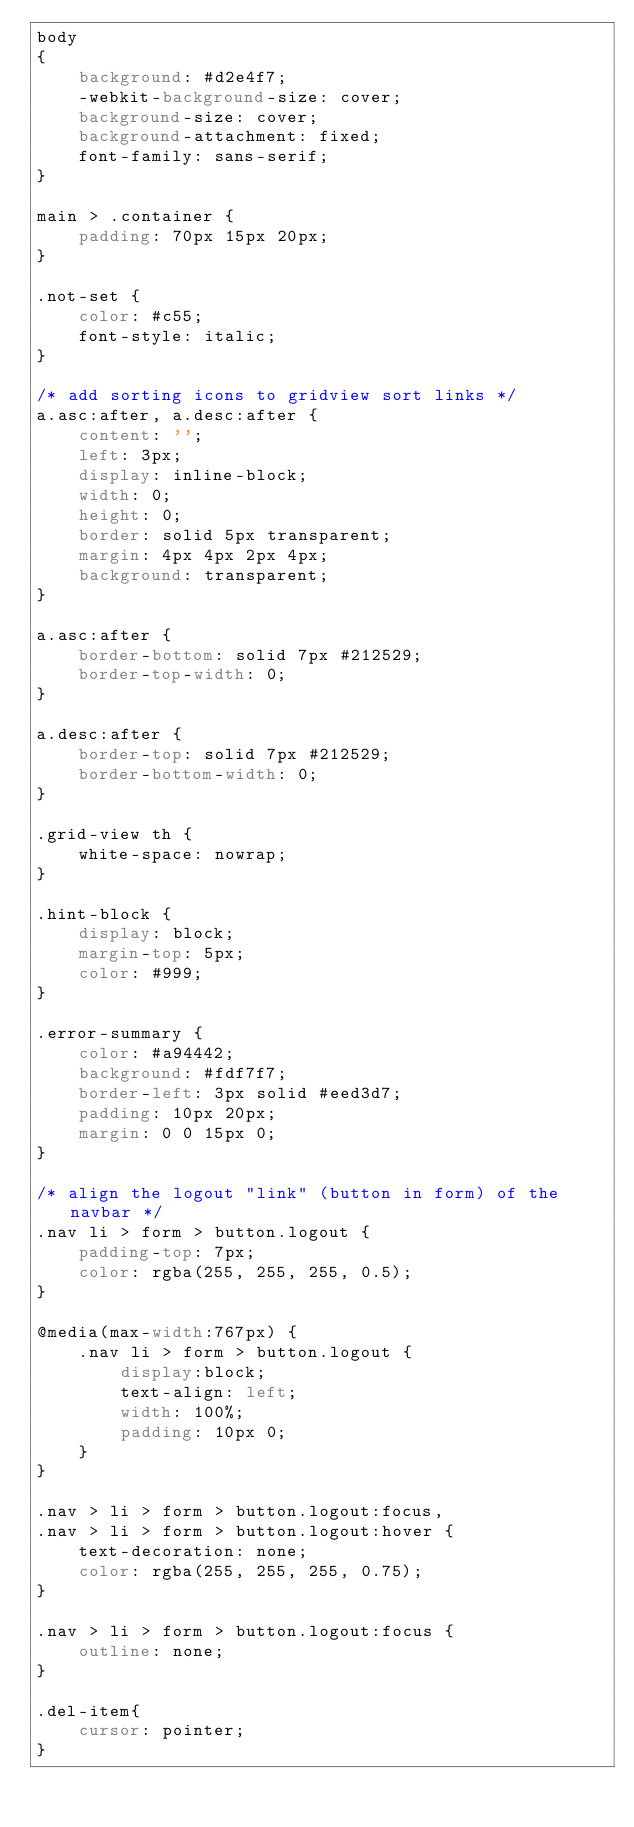<code> <loc_0><loc_0><loc_500><loc_500><_CSS_>body
{
    background: #d2e4f7;
    -webkit-background-size: cover;
    background-size: cover;
    background-attachment: fixed;
    font-family: sans-serif;
}

main > .container {
    padding: 70px 15px 20px;
}

.not-set {
    color: #c55;
    font-style: italic;
}

/* add sorting icons to gridview sort links */
a.asc:after, a.desc:after {
    content: '';
    left: 3px;
    display: inline-block;
    width: 0;
    height: 0;
    border: solid 5px transparent;
    margin: 4px 4px 2px 4px;
    background: transparent;
}

a.asc:after {
    border-bottom: solid 7px #212529;
    border-top-width: 0;
}

a.desc:after {
    border-top: solid 7px #212529;
    border-bottom-width: 0;
}

.grid-view th {
    white-space: nowrap;
}

.hint-block {
    display: block;
    margin-top: 5px;
    color: #999;
}

.error-summary {
    color: #a94442;
    background: #fdf7f7;
    border-left: 3px solid #eed3d7;
    padding: 10px 20px;
    margin: 0 0 15px 0;
}

/* align the logout "link" (button in form) of the navbar */
.nav li > form > button.logout {
    padding-top: 7px;
    color: rgba(255, 255, 255, 0.5);
}

@media(max-width:767px) {
    .nav li > form > button.logout {
        display:block;
        text-align: left;
        width: 100%;
        padding: 10px 0;
    }
}

.nav > li > form > button.logout:focus,
.nav > li > form > button.logout:hover {
    text-decoration: none;
    color: rgba(255, 255, 255, 0.75);
}

.nav > li > form > button.logout:focus {
    outline: none;
}

.del-item{
    cursor: pointer;
}</code> 